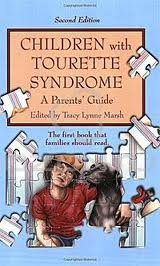Who wrote this book? The book 'Children with Tourette Syndrome - A Parent's Guide' was edited by Tracy Lynne Marsh. 